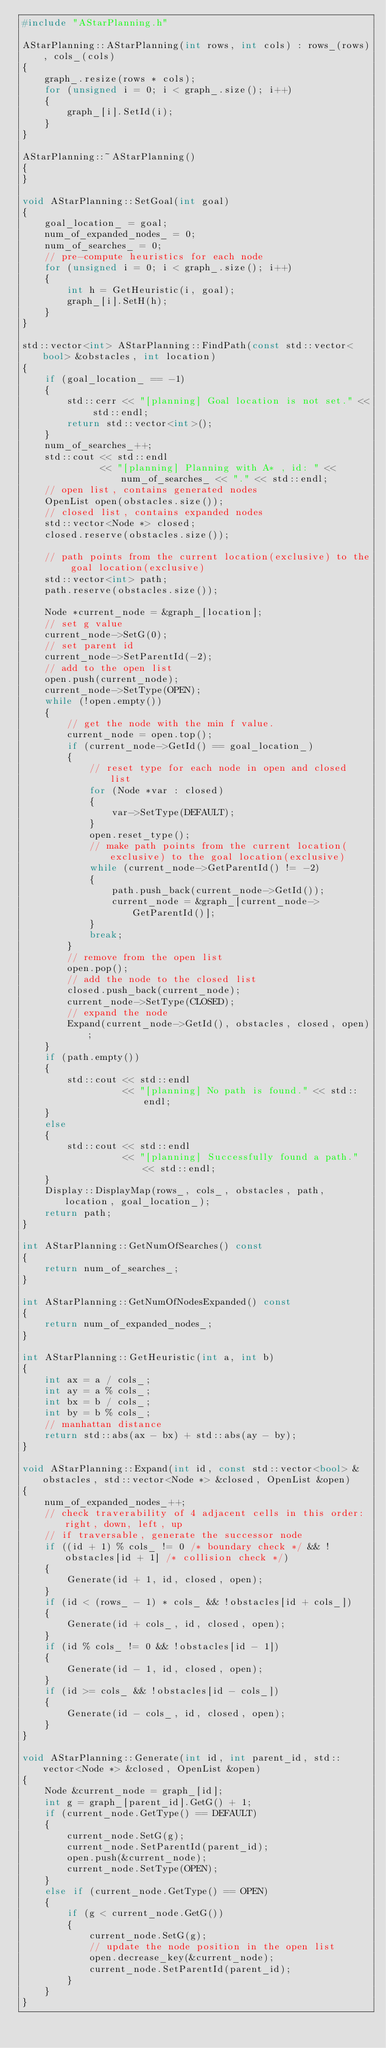Convert code to text. <code><loc_0><loc_0><loc_500><loc_500><_C++_>#include "AStarPlanning.h"

AStarPlanning::AStarPlanning(int rows, int cols) : rows_(rows), cols_(cols)
{
	graph_.resize(rows * cols);
	for (unsigned i = 0; i < graph_.size(); i++)
	{
		graph_[i].SetId(i);
	}
}

AStarPlanning::~AStarPlanning()
{
}

void AStarPlanning::SetGoal(int goal)
{
	goal_location_ = goal;
	num_of_expanded_nodes_ = 0;
	num_of_searches_ = 0;
	// pre-compute heuristics for each node
	for (unsigned i = 0; i < graph_.size(); i++)
	{
		int h = GetHeuristic(i, goal);
		graph_[i].SetH(h);
	}
}

std::vector<int> AStarPlanning::FindPath(const std::vector<bool> &obstacles, int location)
{
	if (goal_location_ == -1)
	{
		std::cerr << "[planning] Goal location is not set." << std::endl;
		return std::vector<int>();
	}
	num_of_searches_++;
	std::cout << std::endl
			  << "[planning] Planning with A* , id: " << num_of_searches_ << "." << std::endl;
	// open list, contains generated nodes
	OpenList open(obstacles.size());
	// closed list, contains expanded nodes
	std::vector<Node *> closed;
	closed.reserve(obstacles.size());

	// path points from the current location(exclusive) to the goal location(exclusive)
	std::vector<int> path;
	path.reserve(obstacles.size());

	Node *current_node = &graph_[location];
	// set g value
	current_node->SetG(0);
	// set parent id
	current_node->SetParentId(-2);
	// add to the open list
	open.push(current_node);
	current_node->SetType(OPEN);
	while (!open.empty())
	{
		// get the node with the min f value.
		current_node = open.top();
		if (current_node->GetId() == goal_location_)
		{
			// reset type for each node in open and closed list
			for (Node *var : closed)
			{
				var->SetType(DEFAULT);
			}
			open.reset_type();
			// make path points from the current location(exclusive) to the goal location(exclusive)
			while (current_node->GetParentId() != -2)
			{
				path.push_back(current_node->GetId());
				current_node = &graph_[current_node->GetParentId()];
			}
			break;
		}
		// remove from the open list
		open.pop();
		// add the node to the closed list
		closed.push_back(current_node);
		current_node->SetType(CLOSED);
		// expand the node
		Expand(current_node->GetId(), obstacles, closed, open);
	}
	if (path.empty())
	{
		std::cout << std::endl
				  << "[planning] No path is found." << std::endl;
	}
	else
	{
		std::cout << std::endl
				  << "[planning] Successfully found a path." << std::endl;
	}
	Display::DisplayMap(rows_, cols_, obstacles, path, location, goal_location_);
	return path;
}

int AStarPlanning::GetNumOfSearches() const
{
	return num_of_searches_;
}

int AStarPlanning::GetNumOfNodesExpanded() const
{
	return num_of_expanded_nodes_;
}

int AStarPlanning::GetHeuristic(int a, int b)
{
	int ax = a / cols_;
	int ay = a % cols_;
	int bx = b / cols_;
	int by = b % cols_;
	// manhattan distance
	return std::abs(ax - bx) + std::abs(ay - by);
}

void AStarPlanning::Expand(int id, const std::vector<bool> &obstacles, std::vector<Node *> &closed, OpenList &open)
{
	num_of_expanded_nodes_++;
	// check traverability of 4 adjacent cells in this order: right, down, left, up
	// if traversable, generate the successor node
	if ((id + 1) % cols_ != 0 /* boundary check */ && !obstacles[id + 1] /* collision check */)
	{
		Generate(id + 1, id, closed, open);
	}
	if (id < (rows_ - 1) * cols_ && !obstacles[id + cols_])
	{
		Generate(id + cols_, id, closed, open);
	}
	if (id % cols_ != 0 && !obstacles[id - 1])
	{
		Generate(id - 1, id, closed, open);
	}
	if (id >= cols_ && !obstacles[id - cols_])
	{
		Generate(id - cols_, id, closed, open);
	}
}

void AStarPlanning::Generate(int id, int parent_id, std::vector<Node *> &closed, OpenList &open)
{
	Node &current_node = graph_[id];
	int g = graph_[parent_id].GetG() + 1;
	if (current_node.GetType() == DEFAULT)
	{
		current_node.SetG(g);
		current_node.SetParentId(parent_id);
		open.push(&current_node);
		current_node.SetType(OPEN);
	}
	else if (current_node.GetType() == OPEN)
	{
		if (g < current_node.GetG())
		{
			current_node.SetG(g);
			// update the node position in the open list
			open.decrease_key(&current_node);
			current_node.SetParentId(parent_id);
		}
	}
}
</code> 